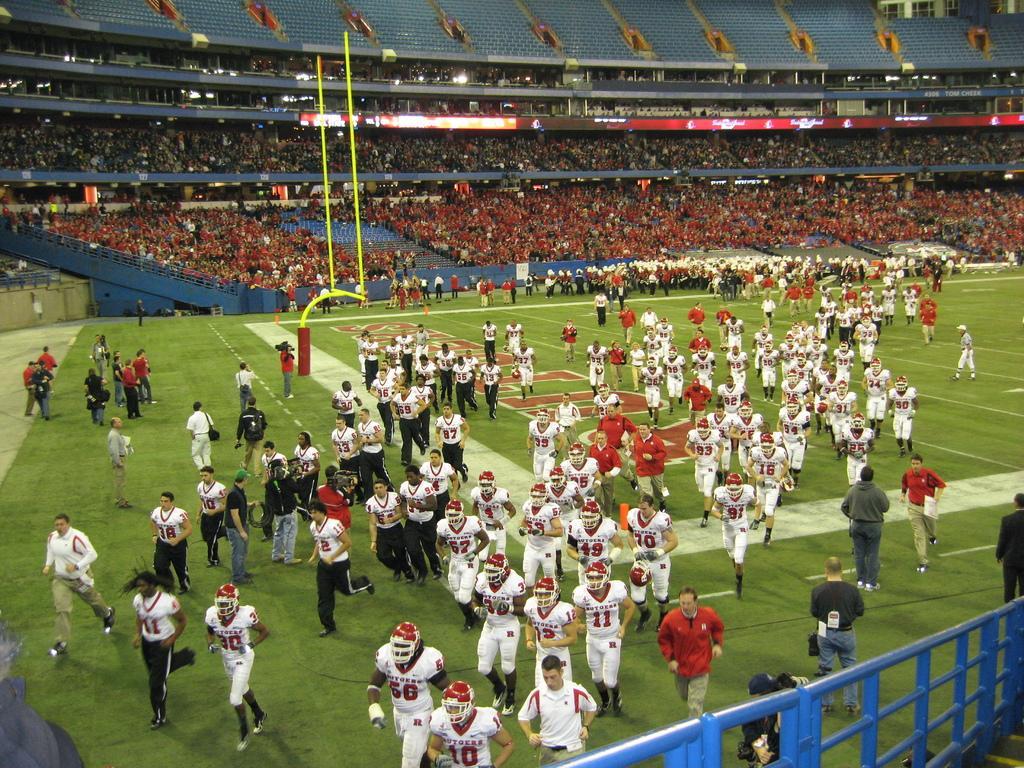Could you give a brief overview of what you see in this image? In the foreground I can see a fence, crowd on the ground, box, staircase and boards. In the background I can see a crowd in the stadium, lights and buildings. This image is taken may be during night on the ground. 